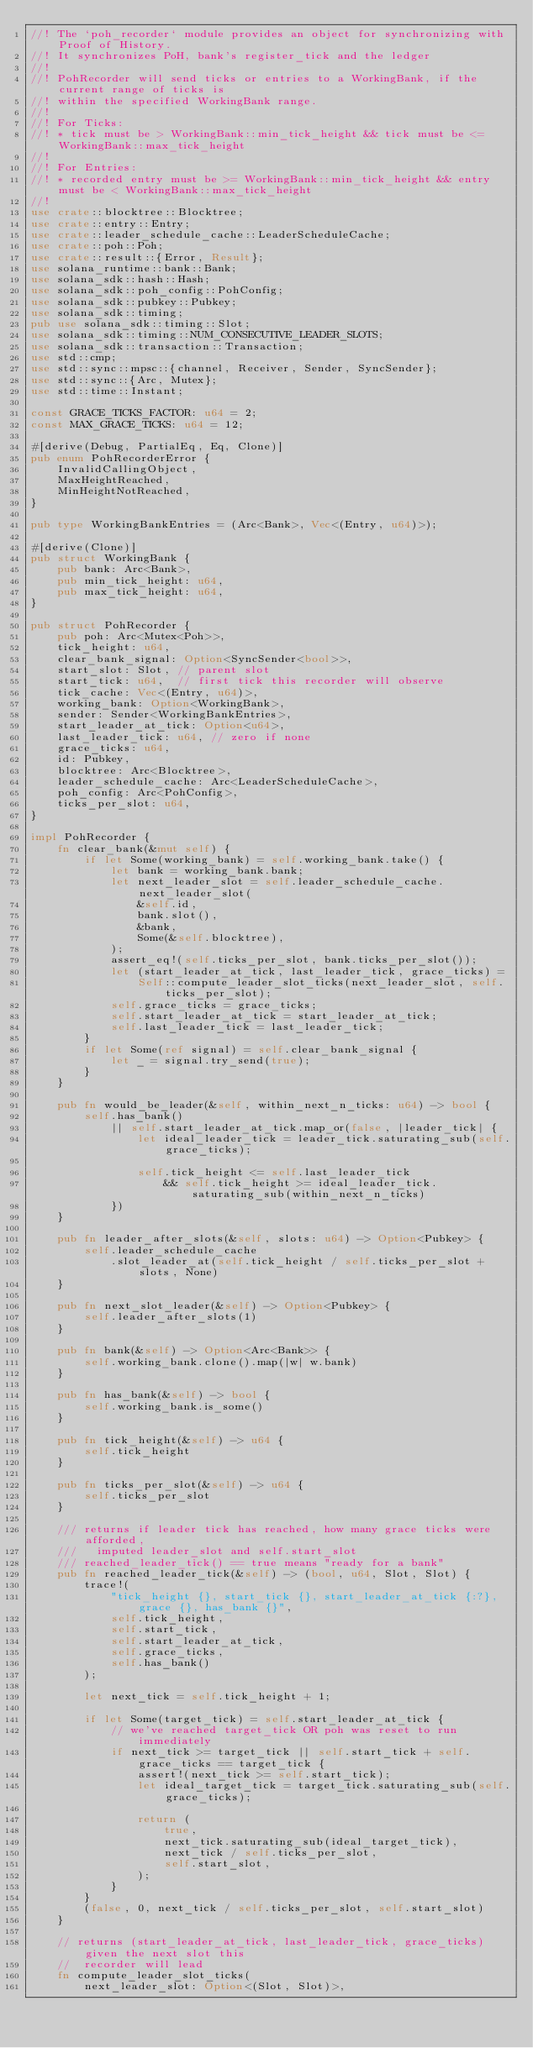<code> <loc_0><loc_0><loc_500><loc_500><_Rust_>//! The `poh_recorder` module provides an object for synchronizing with Proof of History.
//! It synchronizes PoH, bank's register_tick and the ledger
//!
//! PohRecorder will send ticks or entries to a WorkingBank, if the current range of ticks is
//! within the specified WorkingBank range.
//!
//! For Ticks:
//! * tick must be > WorkingBank::min_tick_height && tick must be <= WorkingBank::max_tick_height
//!
//! For Entries:
//! * recorded entry must be >= WorkingBank::min_tick_height && entry must be < WorkingBank::max_tick_height
//!
use crate::blocktree::Blocktree;
use crate::entry::Entry;
use crate::leader_schedule_cache::LeaderScheduleCache;
use crate::poh::Poh;
use crate::result::{Error, Result};
use solana_runtime::bank::Bank;
use solana_sdk::hash::Hash;
use solana_sdk::poh_config::PohConfig;
use solana_sdk::pubkey::Pubkey;
use solana_sdk::timing;
pub use solana_sdk::timing::Slot;
use solana_sdk::timing::NUM_CONSECUTIVE_LEADER_SLOTS;
use solana_sdk::transaction::Transaction;
use std::cmp;
use std::sync::mpsc::{channel, Receiver, Sender, SyncSender};
use std::sync::{Arc, Mutex};
use std::time::Instant;

const GRACE_TICKS_FACTOR: u64 = 2;
const MAX_GRACE_TICKS: u64 = 12;

#[derive(Debug, PartialEq, Eq, Clone)]
pub enum PohRecorderError {
    InvalidCallingObject,
    MaxHeightReached,
    MinHeightNotReached,
}

pub type WorkingBankEntries = (Arc<Bank>, Vec<(Entry, u64)>);

#[derive(Clone)]
pub struct WorkingBank {
    pub bank: Arc<Bank>,
    pub min_tick_height: u64,
    pub max_tick_height: u64,
}

pub struct PohRecorder {
    pub poh: Arc<Mutex<Poh>>,
    tick_height: u64,
    clear_bank_signal: Option<SyncSender<bool>>,
    start_slot: Slot, // parent slot
    start_tick: u64,  // first tick this recorder will observe
    tick_cache: Vec<(Entry, u64)>,
    working_bank: Option<WorkingBank>,
    sender: Sender<WorkingBankEntries>,
    start_leader_at_tick: Option<u64>,
    last_leader_tick: u64, // zero if none
    grace_ticks: u64,
    id: Pubkey,
    blocktree: Arc<Blocktree>,
    leader_schedule_cache: Arc<LeaderScheduleCache>,
    poh_config: Arc<PohConfig>,
    ticks_per_slot: u64,
}

impl PohRecorder {
    fn clear_bank(&mut self) {
        if let Some(working_bank) = self.working_bank.take() {
            let bank = working_bank.bank;
            let next_leader_slot = self.leader_schedule_cache.next_leader_slot(
                &self.id,
                bank.slot(),
                &bank,
                Some(&self.blocktree),
            );
            assert_eq!(self.ticks_per_slot, bank.ticks_per_slot());
            let (start_leader_at_tick, last_leader_tick, grace_ticks) =
                Self::compute_leader_slot_ticks(next_leader_slot, self.ticks_per_slot);
            self.grace_ticks = grace_ticks;
            self.start_leader_at_tick = start_leader_at_tick;
            self.last_leader_tick = last_leader_tick;
        }
        if let Some(ref signal) = self.clear_bank_signal {
            let _ = signal.try_send(true);
        }
    }

    pub fn would_be_leader(&self, within_next_n_ticks: u64) -> bool {
        self.has_bank()
            || self.start_leader_at_tick.map_or(false, |leader_tick| {
                let ideal_leader_tick = leader_tick.saturating_sub(self.grace_ticks);

                self.tick_height <= self.last_leader_tick
                    && self.tick_height >= ideal_leader_tick.saturating_sub(within_next_n_ticks)
            })
    }

    pub fn leader_after_slots(&self, slots: u64) -> Option<Pubkey> {
        self.leader_schedule_cache
            .slot_leader_at(self.tick_height / self.ticks_per_slot + slots, None)
    }

    pub fn next_slot_leader(&self) -> Option<Pubkey> {
        self.leader_after_slots(1)
    }

    pub fn bank(&self) -> Option<Arc<Bank>> {
        self.working_bank.clone().map(|w| w.bank)
    }

    pub fn has_bank(&self) -> bool {
        self.working_bank.is_some()
    }

    pub fn tick_height(&self) -> u64 {
        self.tick_height
    }

    pub fn ticks_per_slot(&self) -> u64 {
        self.ticks_per_slot
    }

    /// returns if leader tick has reached, how many grace ticks were afforded,
    ///   imputed leader_slot and self.start_slot
    /// reached_leader_tick() == true means "ready for a bank"
    pub fn reached_leader_tick(&self) -> (bool, u64, Slot, Slot) {
        trace!(
            "tick_height {}, start_tick {}, start_leader_at_tick {:?}, grace {}, has_bank {}",
            self.tick_height,
            self.start_tick,
            self.start_leader_at_tick,
            self.grace_ticks,
            self.has_bank()
        );

        let next_tick = self.tick_height + 1;

        if let Some(target_tick) = self.start_leader_at_tick {
            // we've reached target_tick OR poh was reset to run immediately
            if next_tick >= target_tick || self.start_tick + self.grace_ticks == target_tick {
                assert!(next_tick >= self.start_tick);
                let ideal_target_tick = target_tick.saturating_sub(self.grace_ticks);

                return (
                    true,
                    next_tick.saturating_sub(ideal_target_tick),
                    next_tick / self.ticks_per_slot,
                    self.start_slot,
                );
            }
        }
        (false, 0, next_tick / self.ticks_per_slot, self.start_slot)
    }

    // returns (start_leader_at_tick, last_leader_tick, grace_ticks) given the next slot this
    //  recorder will lead
    fn compute_leader_slot_ticks(
        next_leader_slot: Option<(Slot, Slot)>,</code> 